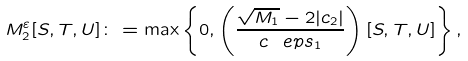<formula> <loc_0><loc_0><loc_500><loc_500>M _ { 2 } ^ { \varepsilon } [ S , T , U ] \colon = \max \left \{ 0 , \left ( \frac { \sqrt { M _ { 1 } } - 2 | c _ { 2 } | } { c ^ { \ } e p s _ { 1 } } \right ) [ S , T , U ] \right \} ,</formula> 